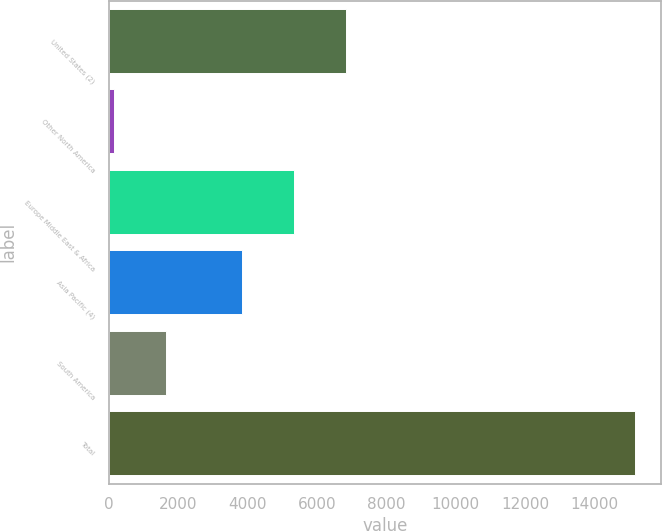Convert chart. <chart><loc_0><loc_0><loc_500><loc_500><bar_chart><fcel>United States (2)<fcel>Other North America<fcel>Europe Middle East & Africa<fcel>Asia Pacific (4)<fcel>South America<fcel>Total<nl><fcel>6842.8<fcel>146<fcel>5340.9<fcel>3839<fcel>1647.9<fcel>15165<nl></chart> 